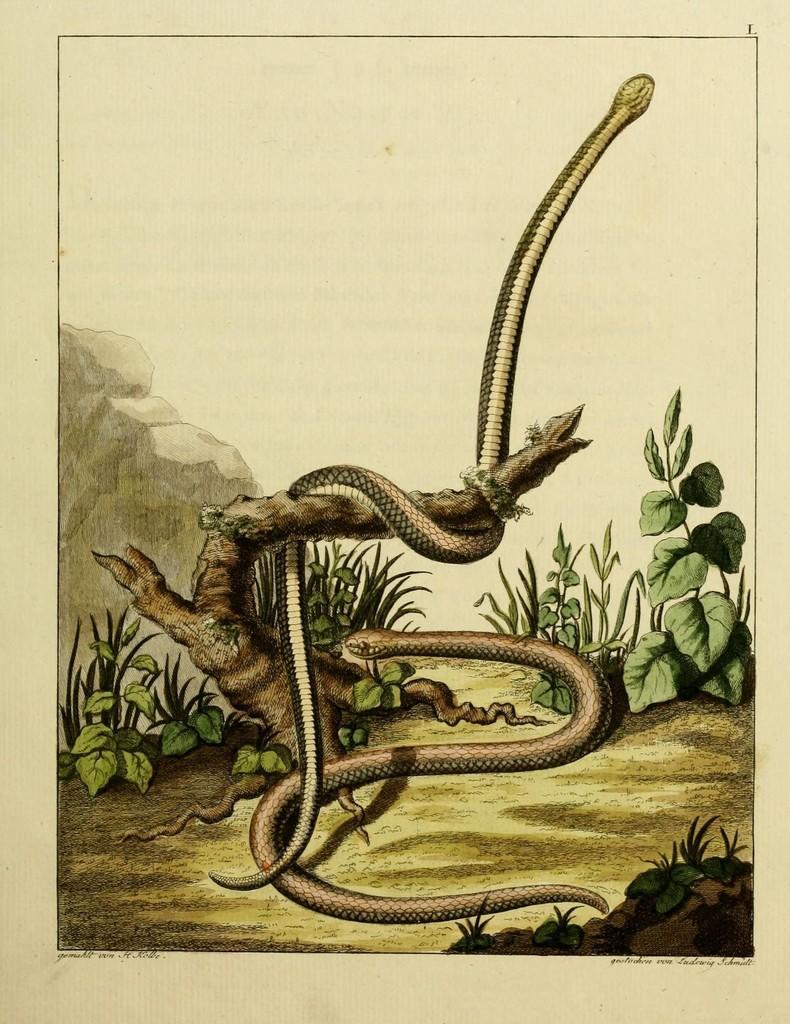Can you describe this image briefly? In this picture there is a poster of a painting. In the painting I can see the long snake on the tree branch. At the bottom I can see another snake on the ground, beside that I can see the plants. On the left there is a mountain. At the top there is a sky. 